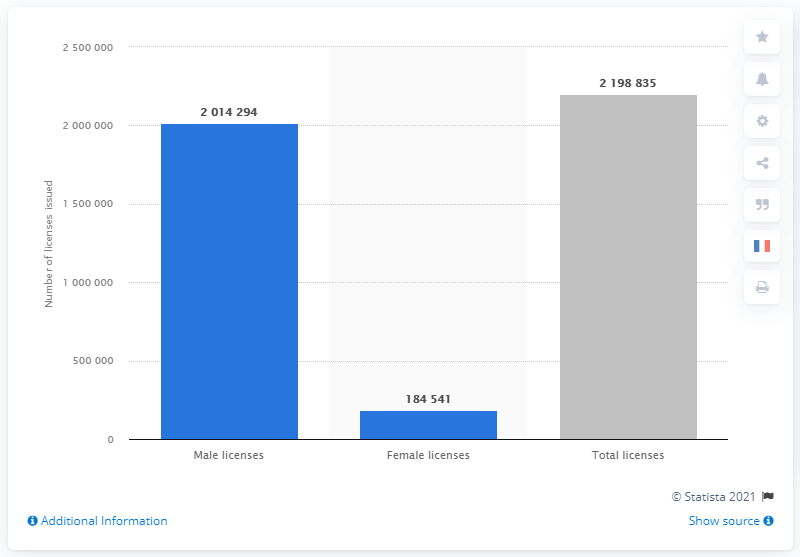Highlight a few significant elements in this photo. The French Soccer Federation had 2019 licensed players, which consisted of 294,000 individuals. In 2019, the number of registered members in soccer was 2198835. 